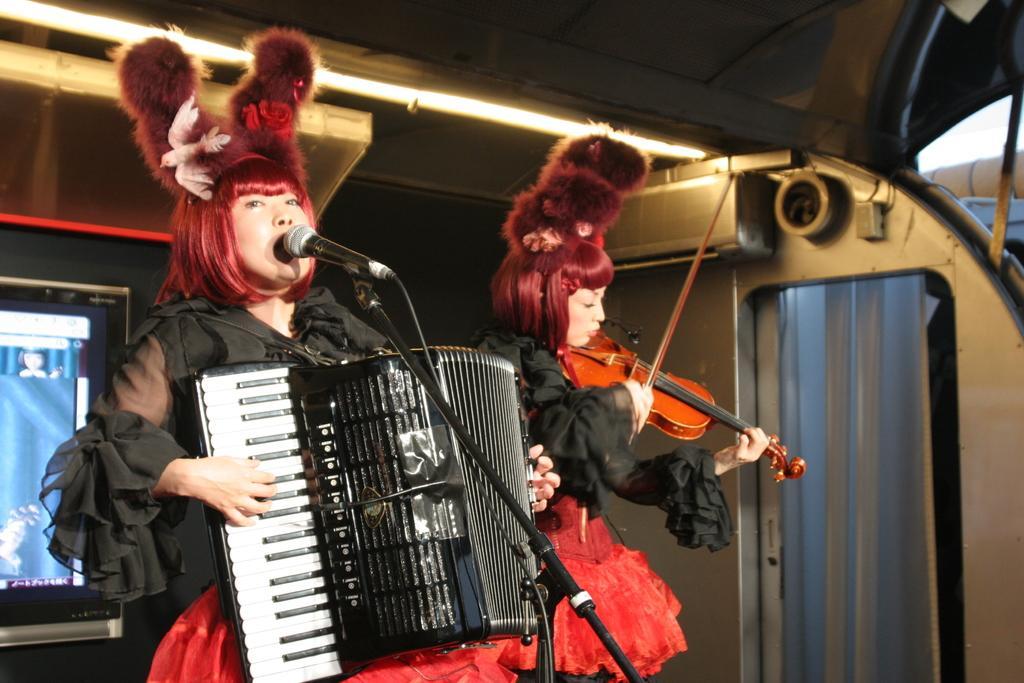In one or two sentences, can you explain what this image depicts? In this image there are two persons standing and playing musical instrument. At the back there is a screen and at the right there is a door, at the top there is a light, in the there is a microphone. 